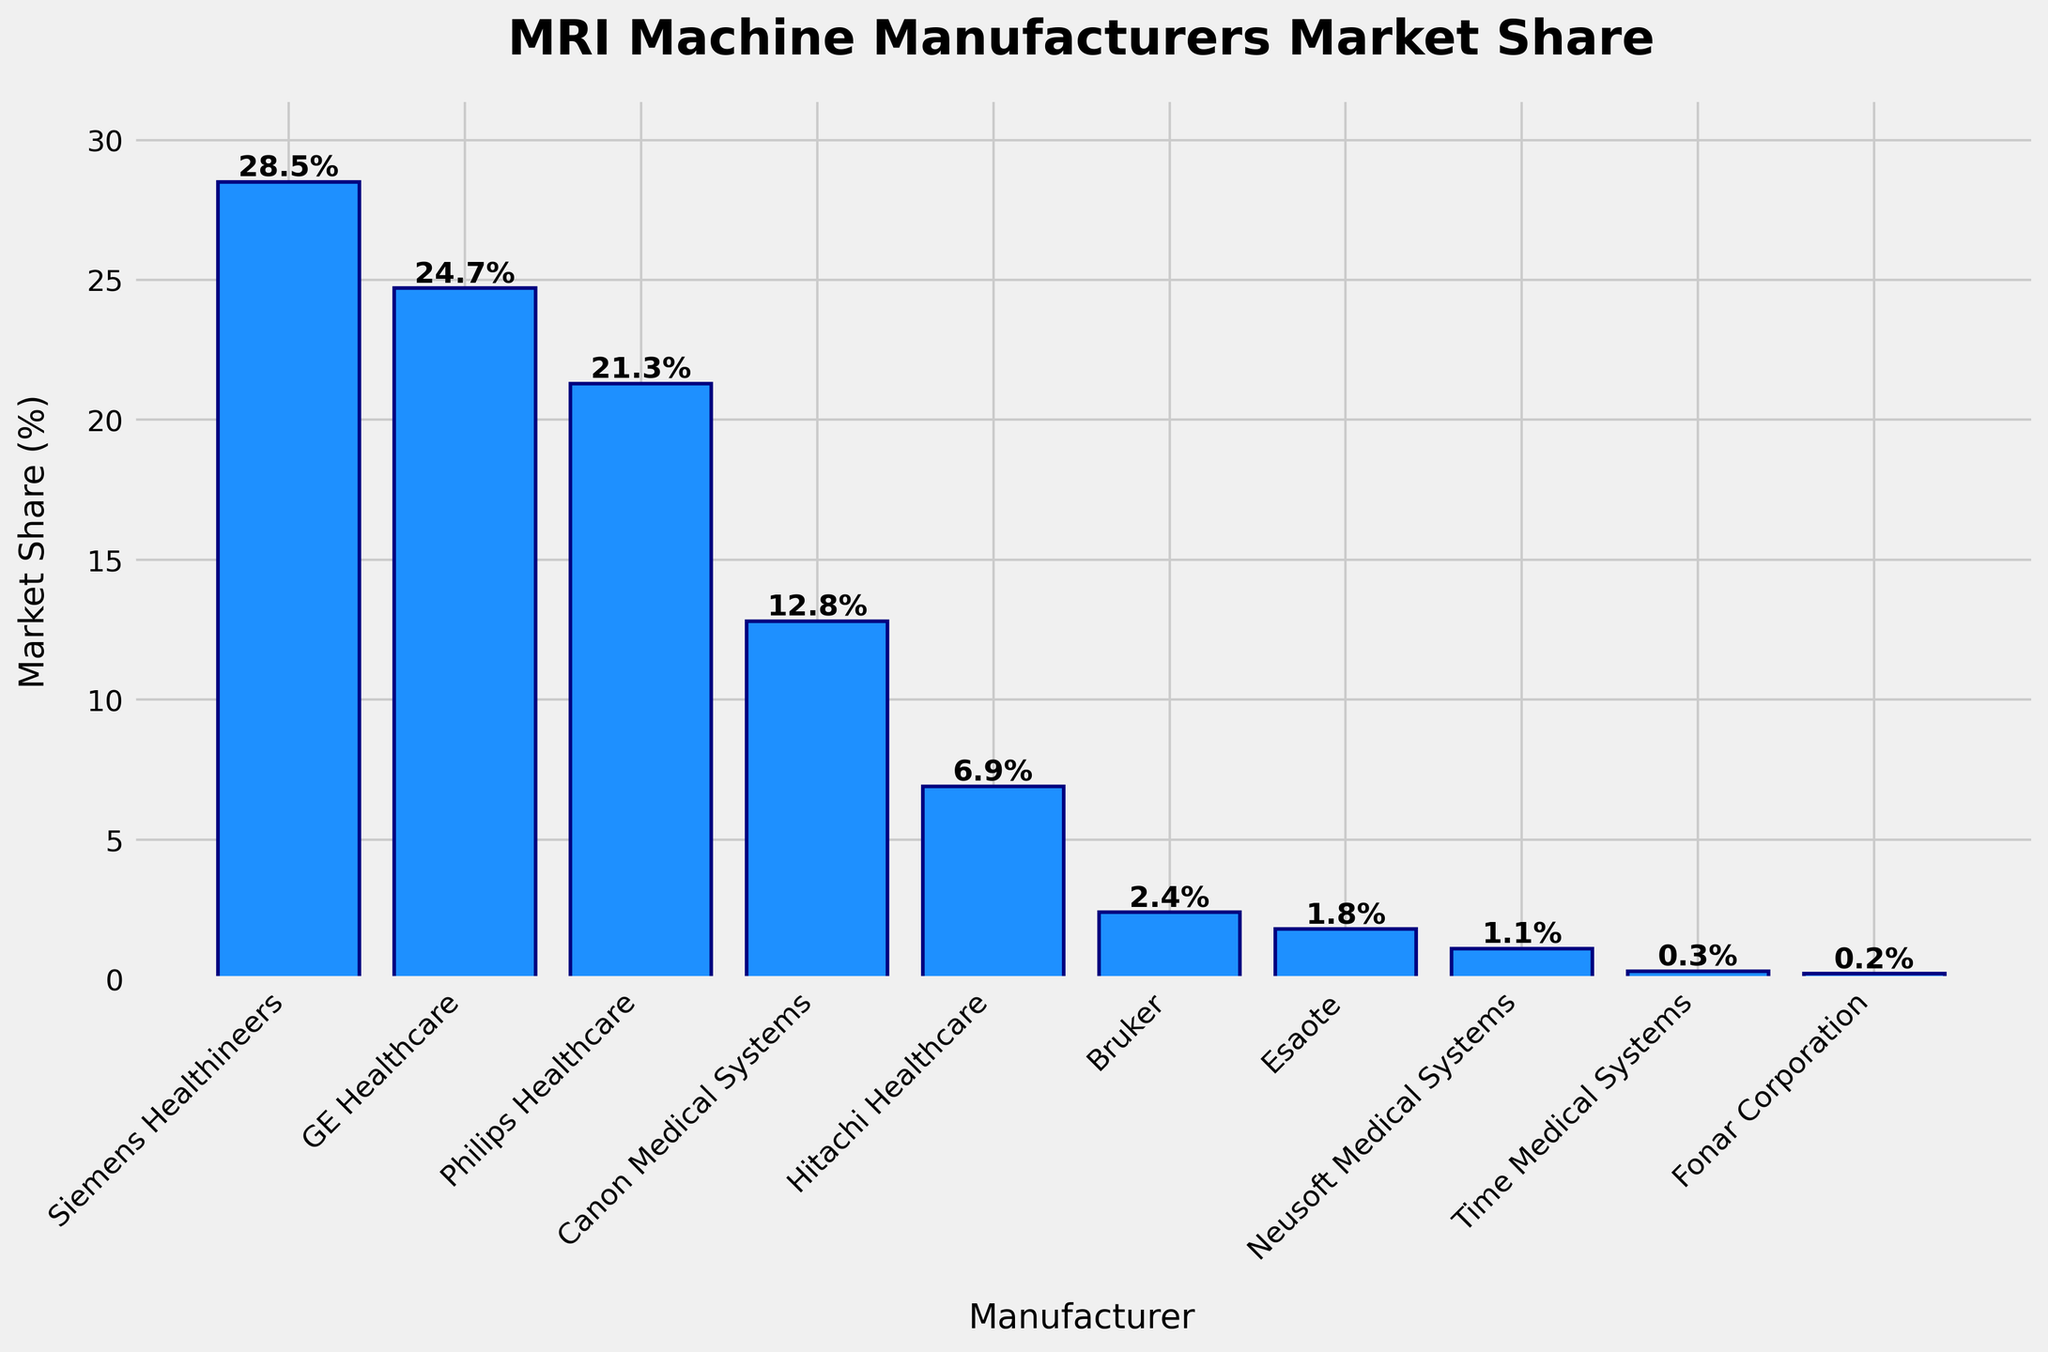Which manufacturer has the highest market share? By visually examining the heights of the bars, Siemens Healthineers has the tallest bar, indicating it has the highest market share.
Answer: Siemens Healthineers What is the combined market share of Canon Medical Systems and Hitachi Healthcare? Canon Medical Systems has a market share of 12.8% and Hitachi Healthcare has 6.9%. Adding them together gives 12.8 + 6.9.
Answer: 19.7% Which manufacturer has the lowest market share and what is it? By identifying the shortest bar, the manufacturer with the lowest market share is Fonar Corporation with a 0.2%.
Answer: Fonar Corporation, 0.2% What is the difference in market share between GE Healthcare and Philips Healthcare? GE Healthcare has a market share of 24.7% and Philips Healthcare has 21.3%. The difference is 24.7 - 21.3.
Answer: 3.4% How much more market share does Siemens Healthineers have compared to the combined market share of Esaote and Neusoft Medical Systems? Siemens Healthineers has a market share of 28.5%. Esaote has 1.8% and Neusoft Medical Systems has 1.1%, their combined share is 1.8 + 1.1 = 2.9%. The difference is 28.5 - 2.9.
Answer: 25.6% How many manufacturers have a market share greater than 20%? By looking at the heights of the bars, Siemens Healthineers, GE Healthcare, and Philips Healthcare have market shares greater than 20%. Count these bars.
Answer: 3 What is the total market share represented by the given manufacturers? Add all the market shares: 28.5 + 24.7 + 21.3 + 12.8 + 6.9 + 2.4 + 1.8 + 1.1 + 0.3 + 0.2.
Answer: 100% Between Canon Medical Systems and Bruker, which has a higher market share and by how much? Canon Medical Systems has a market share of 12.8% and Bruker has 2.4%. The difference is 12.8 - 2.4.
Answer: Canon Medical Systems by 10.4% Which manufacturers have a market share that is less than 5%? By examining the heights of the bars, the manufacturers with less than 5% market share are Bruker, Esaote, Neusoft Medical Systems, Time Medical Systems, and Fonar Corporation.
Answer: Bruker, Esaote, Neusoft Medical Systems, Time Medical Systems, Fonar Corporation What is the average market share of the top three manufacturers? The top three manufacturers are Siemens Healthineers (28.5%), GE Healthcare (24.7%), and Philips Healthcare (21.3%). Their average share is (28.5 + 24.7 + 21.3) / 3.
Answer: 24.83% 